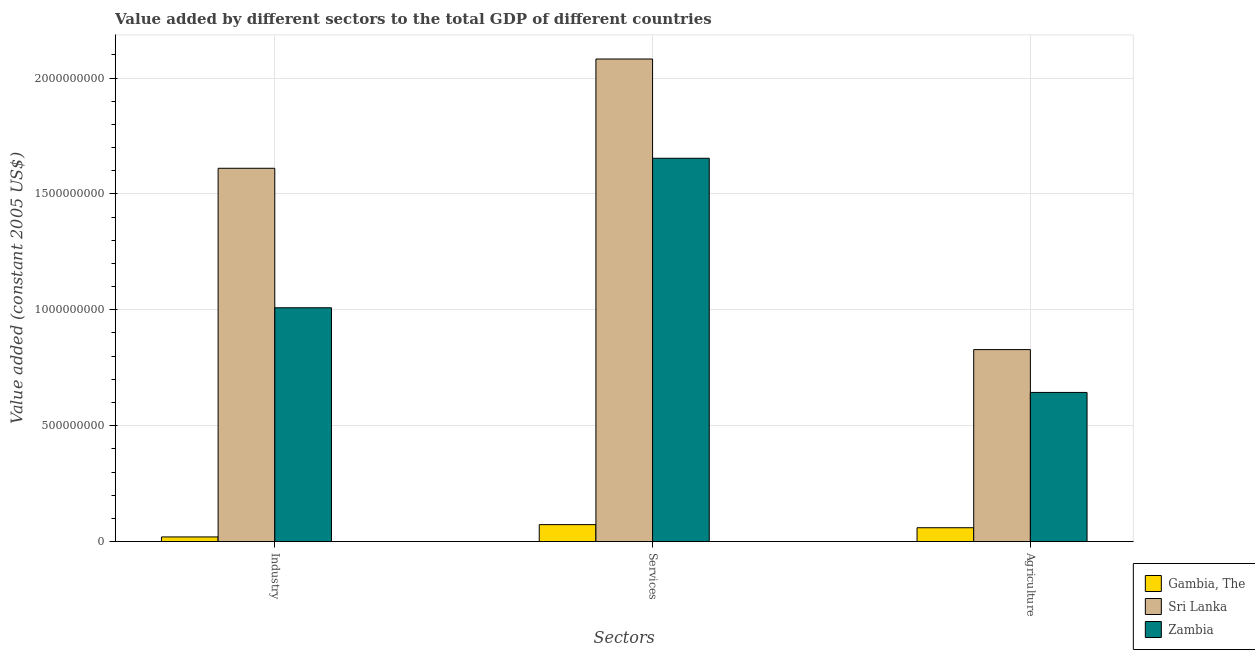How many different coloured bars are there?
Make the answer very short. 3. How many groups of bars are there?
Keep it short and to the point. 3. How many bars are there on the 3rd tick from the right?
Your answer should be compact. 3. What is the label of the 1st group of bars from the left?
Your response must be concise. Industry. What is the value added by agricultural sector in Zambia?
Your answer should be compact. 6.43e+08. Across all countries, what is the maximum value added by industrial sector?
Ensure brevity in your answer.  1.61e+09. Across all countries, what is the minimum value added by industrial sector?
Give a very brief answer. 2.00e+07. In which country was the value added by industrial sector maximum?
Your response must be concise. Sri Lanka. In which country was the value added by services minimum?
Offer a terse response. Gambia, The. What is the total value added by industrial sector in the graph?
Your response must be concise. 2.64e+09. What is the difference between the value added by agricultural sector in Zambia and that in Gambia, The?
Offer a very short reply. 5.84e+08. What is the difference between the value added by industrial sector in Zambia and the value added by agricultural sector in Gambia, The?
Make the answer very short. 9.49e+08. What is the average value added by services per country?
Offer a terse response. 1.27e+09. What is the difference between the value added by agricultural sector and value added by services in Gambia, The?
Provide a succinct answer. -1.34e+07. What is the ratio of the value added by agricultural sector in Gambia, The to that in Zambia?
Your answer should be very brief. 0.09. Is the value added by agricultural sector in Zambia less than that in Sri Lanka?
Your answer should be compact. Yes. Is the difference between the value added by agricultural sector in Sri Lanka and Gambia, The greater than the difference between the value added by services in Sri Lanka and Gambia, The?
Your answer should be very brief. No. What is the difference between the highest and the second highest value added by agricultural sector?
Your response must be concise. 1.85e+08. What is the difference between the highest and the lowest value added by agricultural sector?
Ensure brevity in your answer.  7.69e+08. What does the 2nd bar from the left in Services represents?
Give a very brief answer. Sri Lanka. What does the 2nd bar from the right in Industry represents?
Your response must be concise. Sri Lanka. Is it the case that in every country, the sum of the value added by industrial sector and value added by services is greater than the value added by agricultural sector?
Your answer should be very brief. Yes. Are all the bars in the graph horizontal?
Ensure brevity in your answer.  No. How many countries are there in the graph?
Your answer should be very brief. 3. What is the difference between two consecutive major ticks on the Y-axis?
Give a very brief answer. 5.00e+08. Does the graph contain grids?
Ensure brevity in your answer.  Yes. How many legend labels are there?
Ensure brevity in your answer.  3. How are the legend labels stacked?
Offer a terse response. Vertical. What is the title of the graph?
Your response must be concise. Value added by different sectors to the total GDP of different countries. What is the label or title of the X-axis?
Your answer should be very brief. Sectors. What is the label or title of the Y-axis?
Your response must be concise. Value added (constant 2005 US$). What is the Value added (constant 2005 US$) in Gambia, The in Industry?
Provide a succinct answer. 2.00e+07. What is the Value added (constant 2005 US$) in Sri Lanka in Industry?
Give a very brief answer. 1.61e+09. What is the Value added (constant 2005 US$) in Zambia in Industry?
Offer a terse response. 1.01e+09. What is the Value added (constant 2005 US$) in Gambia, The in Services?
Your response must be concise. 7.31e+07. What is the Value added (constant 2005 US$) of Sri Lanka in Services?
Keep it short and to the point. 2.08e+09. What is the Value added (constant 2005 US$) of Zambia in Services?
Make the answer very short. 1.65e+09. What is the Value added (constant 2005 US$) of Gambia, The in Agriculture?
Your answer should be compact. 5.97e+07. What is the Value added (constant 2005 US$) of Sri Lanka in Agriculture?
Offer a very short reply. 8.28e+08. What is the Value added (constant 2005 US$) of Zambia in Agriculture?
Your answer should be compact. 6.43e+08. Across all Sectors, what is the maximum Value added (constant 2005 US$) of Gambia, The?
Your answer should be very brief. 7.31e+07. Across all Sectors, what is the maximum Value added (constant 2005 US$) in Sri Lanka?
Your answer should be compact. 2.08e+09. Across all Sectors, what is the maximum Value added (constant 2005 US$) of Zambia?
Keep it short and to the point. 1.65e+09. Across all Sectors, what is the minimum Value added (constant 2005 US$) of Gambia, The?
Provide a succinct answer. 2.00e+07. Across all Sectors, what is the minimum Value added (constant 2005 US$) of Sri Lanka?
Your response must be concise. 8.28e+08. Across all Sectors, what is the minimum Value added (constant 2005 US$) in Zambia?
Give a very brief answer. 6.43e+08. What is the total Value added (constant 2005 US$) of Gambia, The in the graph?
Provide a short and direct response. 1.53e+08. What is the total Value added (constant 2005 US$) of Sri Lanka in the graph?
Keep it short and to the point. 4.52e+09. What is the total Value added (constant 2005 US$) of Zambia in the graph?
Provide a short and direct response. 3.31e+09. What is the difference between the Value added (constant 2005 US$) of Gambia, The in Industry and that in Services?
Make the answer very short. -5.31e+07. What is the difference between the Value added (constant 2005 US$) of Sri Lanka in Industry and that in Services?
Provide a short and direct response. -4.71e+08. What is the difference between the Value added (constant 2005 US$) of Zambia in Industry and that in Services?
Your answer should be compact. -6.45e+08. What is the difference between the Value added (constant 2005 US$) of Gambia, The in Industry and that in Agriculture?
Offer a very short reply. -3.97e+07. What is the difference between the Value added (constant 2005 US$) of Sri Lanka in Industry and that in Agriculture?
Give a very brief answer. 7.82e+08. What is the difference between the Value added (constant 2005 US$) of Zambia in Industry and that in Agriculture?
Offer a terse response. 3.65e+08. What is the difference between the Value added (constant 2005 US$) of Gambia, The in Services and that in Agriculture?
Your response must be concise. 1.34e+07. What is the difference between the Value added (constant 2005 US$) in Sri Lanka in Services and that in Agriculture?
Keep it short and to the point. 1.25e+09. What is the difference between the Value added (constant 2005 US$) of Zambia in Services and that in Agriculture?
Your answer should be compact. 1.01e+09. What is the difference between the Value added (constant 2005 US$) of Gambia, The in Industry and the Value added (constant 2005 US$) of Sri Lanka in Services?
Your answer should be compact. -2.06e+09. What is the difference between the Value added (constant 2005 US$) of Gambia, The in Industry and the Value added (constant 2005 US$) of Zambia in Services?
Keep it short and to the point. -1.63e+09. What is the difference between the Value added (constant 2005 US$) of Sri Lanka in Industry and the Value added (constant 2005 US$) of Zambia in Services?
Give a very brief answer. -4.31e+07. What is the difference between the Value added (constant 2005 US$) of Gambia, The in Industry and the Value added (constant 2005 US$) of Sri Lanka in Agriculture?
Make the answer very short. -8.08e+08. What is the difference between the Value added (constant 2005 US$) of Gambia, The in Industry and the Value added (constant 2005 US$) of Zambia in Agriculture?
Your response must be concise. -6.23e+08. What is the difference between the Value added (constant 2005 US$) in Sri Lanka in Industry and the Value added (constant 2005 US$) in Zambia in Agriculture?
Your answer should be compact. 9.67e+08. What is the difference between the Value added (constant 2005 US$) in Gambia, The in Services and the Value added (constant 2005 US$) in Sri Lanka in Agriculture?
Offer a very short reply. -7.55e+08. What is the difference between the Value added (constant 2005 US$) in Gambia, The in Services and the Value added (constant 2005 US$) in Zambia in Agriculture?
Your answer should be compact. -5.70e+08. What is the difference between the Value added (constant 2005 US$) of Sri Lanka in Services and the Value added (constant 2005 US$) of Zambia in Agriculture?
Provide a succinct answer. 1.44e+09. What is the average Value added (constant 2005 US$) of Gambia, The per Sectors?
Your answer should be very brief. 5.09e+07. What is the average Value added (constant 2005 US$) in Sri Lanka per Sectors?
Your answer should be very brief. 1.51e+09. What is the average Value added (constant 2005 US$) in Zambia per Sectors?
Keep it short and to the point. 1.10e+09. What is the difference between the Value added (constant 2005 US$) of Gambia, The and Value added (constant 2005 US$) of Sri Lanka in Industry?
Keep it short and to the point. -1.59e+09. What is the difference between the Value added (constant 2005 US$) of Gambia, The and Value added (constant 2005 US$) of Zambia in Industry?
Offer a terse response. -9.89e+08. What is the difference between the Value added (constant 2005 US$) in Sri Lanka and Value added (constant 2005 US$) in Zambia in Industry?
Give a very brief answer. 6.02e+08. What is the difference between the Value added (constant 2005 US$) in Gambia, The and Value added (constant 2005 US$) in Sri Lanka in Services?
Ensure brevity in your answer.  -2.01e+09. What is the difference between the Value added (constant 2005 US$) in Gambia, The and Value added (constant 2005 US$) in Zambia in Services?
Offer a very short reply. -1.58e+09. What is the difference between the Value added (constant 2005 US$) in Sri Lanka and Value added (constant 2005 US$) in Zambia in Services?
Offer a very short reply. 4.28e+08. What is the difference between the Value added (constant 2005 US$) in Gambia, The and Value added (constant 2005 US$) in Sri Lanka in Agriculture?
Your answer should be very brief. -7.69e+08. What is the difference between the Value added (constant 2005 US$) of Gambia, The and Value added (constant 2005 US$) of Zambia in Agriculture?
Give a very brief answer. -5.84e+08. What is the difference between the Value added (constant 2005 US$) of Sri Lanka and Value added (constant 2005 US$) of Zambia in Agriculture?
Make the answer very short. 1.85e+08. What is the ratio of the Value added (constant 2005 US$) in Gambia, The in Industry to that in Services?
Your answer should be compact. 0.27. What is the ratio of the Value added (constant 2005 US$) of Sri Lanka in Industry to that in Services?
Offer a very short reply. 0.77. What is the ratio of the Value added (constant 2005 US$) in Zambia in Industry to that in Services?
Your answer should be very brief. 0.61. What is the ratio of the Value added (constant 2005 US$) of Gambia, The in Industry to that in Agriculture?
Give a very brief answer. 0.34. What is the ratio of the Value added (constant 2005 US$) in Sri Lanka in Industry to that in Agriculture?
Make the answer very short. 1.94. What is the ratio of the Value added (constant 2005 US$) of Zambia in Industry to that in Agriculture?
Your answer should be very brief. 1.57. What is the ratio of the Value added (constant 2005 US$) of Gambia, The in Services to that in Agriculture?
Offer a terse response. 1.22. What is the ratio of the Value added (constant 2005 US$) in Sri Lanka in Services to that in Agriculture?
Ensure brevity in your answer.  2.51. What is the ratio of the Value added (constant 2005 US$) of Zambia in Services to that in Agriculture?
Keep it short and to the point. 2.57. What is the difference between the highest and the second highest Value added (constant 2005 US$) in Gambia, The?
Keep it short and to the point. 1.34e+07. What is the difference between the highest and the second highest Value added (constant 2005 US$) in Sri Lanka?
Your answer should be compact. 4.71e+08. What is the difference between the highest and the second highest Value added (constant 2005 US$) of Zambia?
Give a very brief answer. 6.45e+08. What is the difference between the highest and the lowest Value added (constant 2005 US$) in Gambia, The?
Keep it short and to the point. 5.31e+07. What is the difference between the highest and the lowest Value added (constant 2005 US$) of Sri Lanka?
Your response must be concise. 1.25e+09. What is the difference between the highest and the lowest Value added (constant 2005 US$) in Zambia?
Provide a short and direct response. 1.01e+09. 